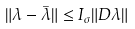<formula> <loc_0><loc_0><loc_500><loc_500>\| \lambda - \overset { \_ } { \lambda } \| \leq I _ { \sigma } \| D \lambda \|</formula> 